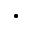Convert formula to latex. <formula><loc_0><loc_0><loc_500><loc_500>\bullet</formula> 